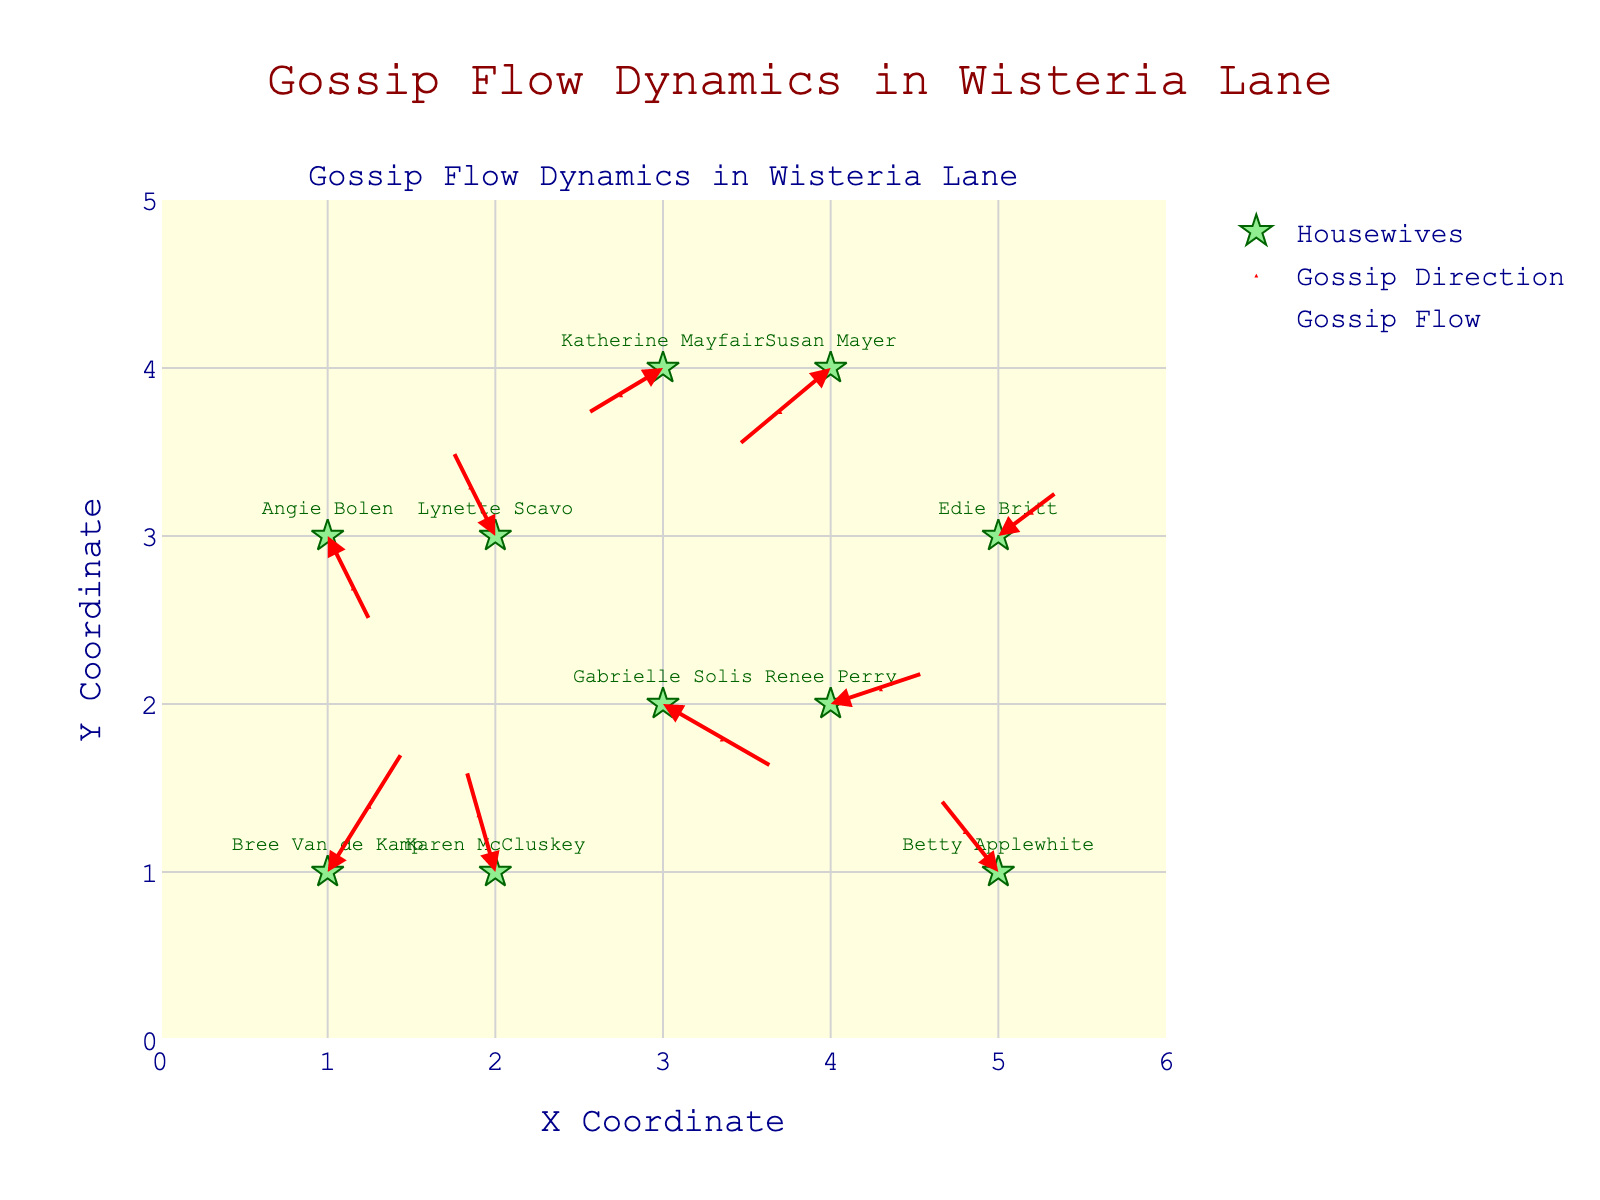What is the title of the figure? The title is the text usually located at the top of the figure. It gives an overview of what the plot represents. For this specific plot, the title is "Gossip Flow Dynamics in Wisteria Lane" as indicated directly at the top center of the figure.
Answer: Gossip Flow Dynamics in Wisteria Lane Which housewife has the largest arrow indicating gossip flow direction? To determine the largest arrow, we look at the magnitudes of gossip flow. Susan Mayer has the highest magnitude of 0.7, indicating she has the largest arrow in terms of gossip flow direction.
Answer: Susan Mayer How many housewives are represented in the plot? Each housewife is marked as a star with their name displayed next to it. By counting the labeled stars, we can see there are 10 housewives present in the plot.
Answer: 10 Which housewife is located at coordinate (3, 2)? By checking the coordinates provided for each housewife, we find that Gabrielle Solis is located at (3, 2).
Answer: Gabrielle Solis What is the direction of gossip flow for Karen McCluskey? The direction of the gossip flow is indicated by the arrow's orientation stemming from Karen McCluskey's position at (2, 1). Her arrow points upwards and slightly to the left, indicating a negative x-direction and a positive y-direction.
Answer: Up and left What is the combined x-component of gossip flow for Bree Van de Kamp and Renee Perry? The x-component (U) for Bree Van de Kamp is 0.5, and for Renee Perry, it is 0.6. Adding these together, the combined x-component is 0.5 + 0.6.
Answer: 1.1 Compare the gossip flow magnitudes between Edie Britt and Angie Bolen. Which one is higher? Edie Britt has a magnitude of 0.3, and Angie Bolen has a magnitude of 0.5. By comparing the two magnitudes, we can see that Angie Bolen has a higher gossip flow magnitude.
Answer: Angie Bolen Which housewife's gossip flow direction has a negative y-component and is situated at the highest y-coordinate? We need to identify the housewife with a negative y-component (V) and situated at the highest y-coordinate point. Susan Mayer at (4, 4) has a negative y-component of -0.5, which is the highest y-coordinate fitting this criterion.
Answer: Susan Mayer Who are the neighbors directly to the north and east of Lynette Scavo? Lynette Scavo is located at (2, 3). The neighbors to the north would have a higher y-coordinate at the same x, and to the east would have a higher x-coordinate at the same y. There is no direct neighbor to the north on this plot, but Susan Mayer at (4, 4) is directly northeast of her, while Bree Van de Kamp at (1, 1) is to the southeast.
Answer: None directly north, Susan Mayer directly northeast, Bree Van de Kamp to the southeast What are the coordinates of the origin of the gossip flow for Katherine Mayfair? We identify the point where Katherine Mayfair's label appears, which is at (3, 4).
Answer: (3, 4) 